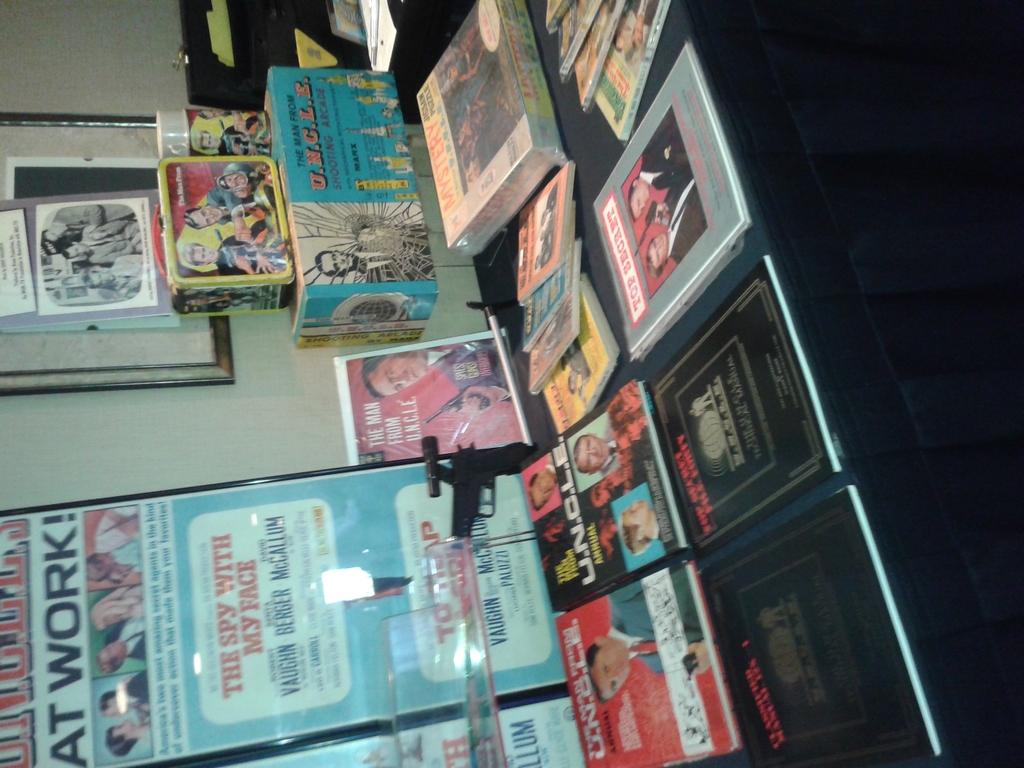<image>
Write a terse but informative summary of the picture. Book fair with an ad in the back that says "The Spy with My Face". 